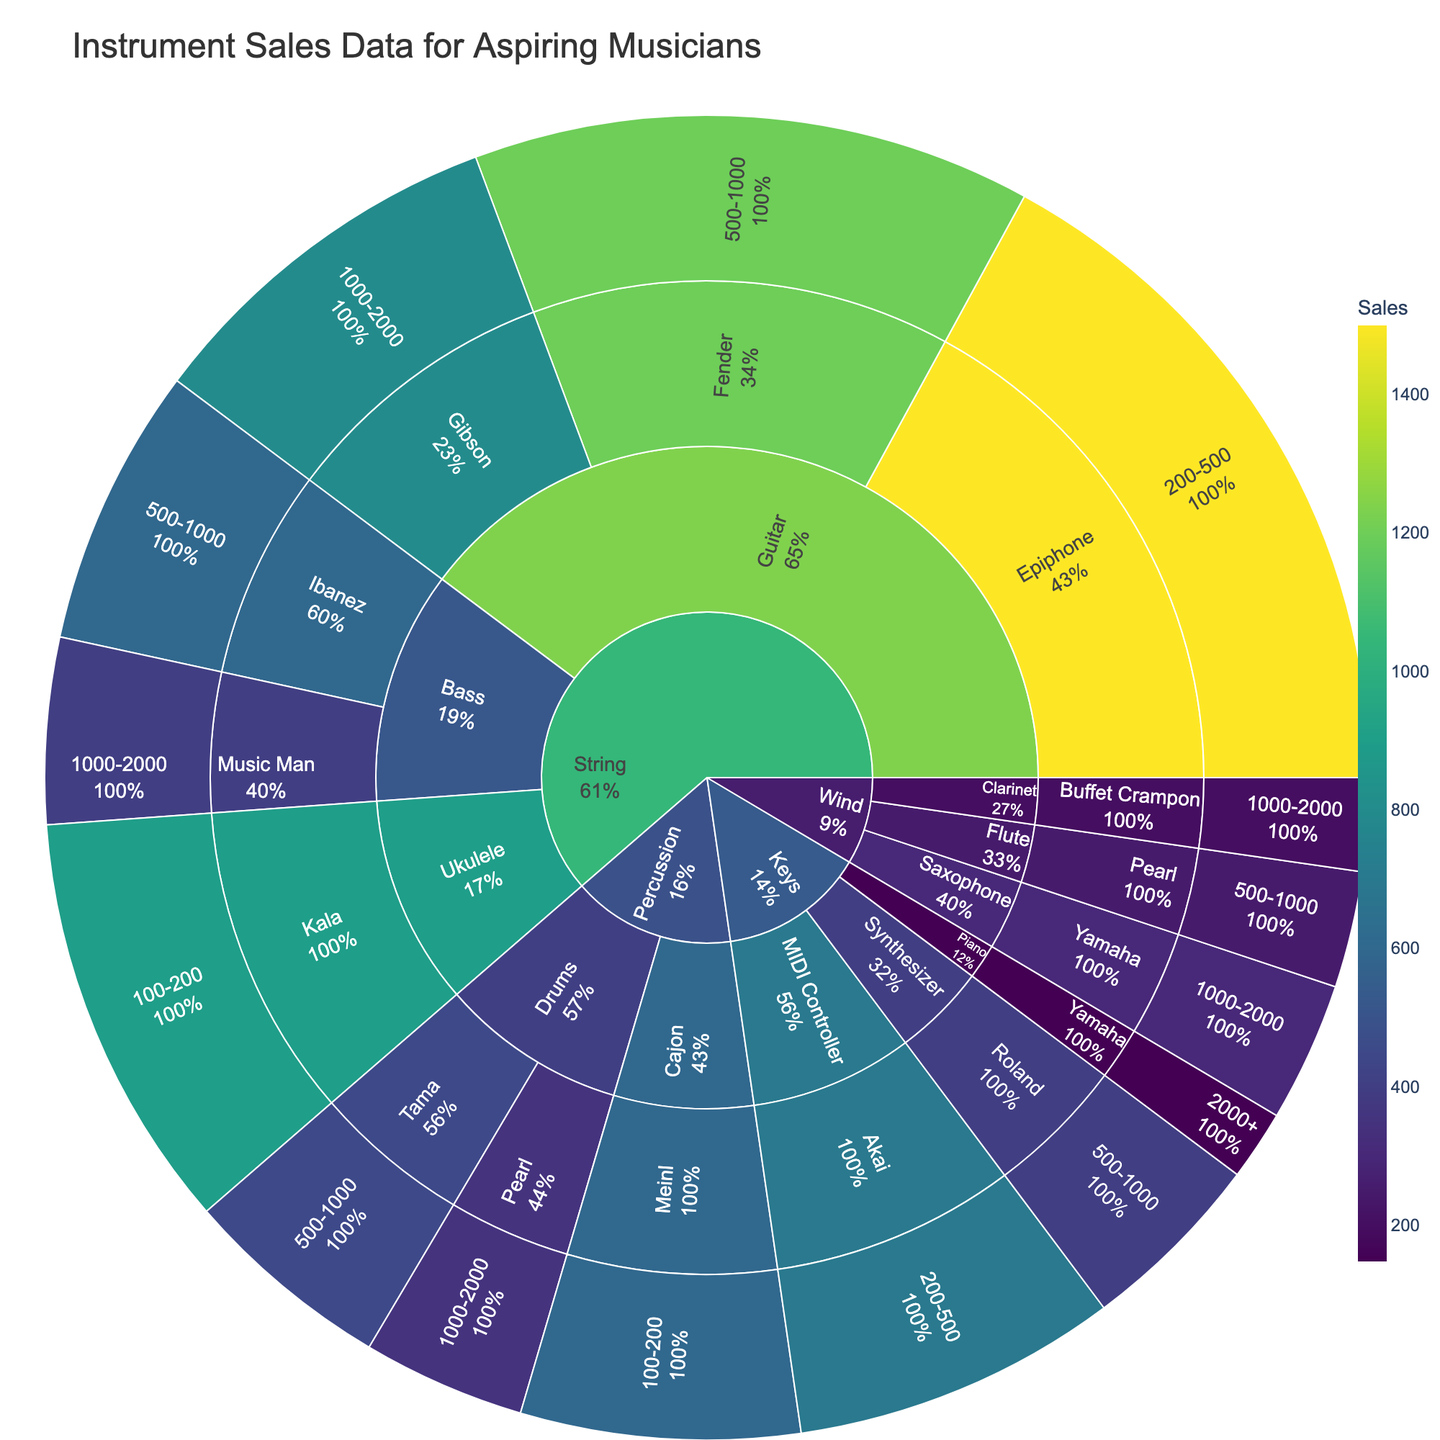what's the sales volume for Epiphone guitars? Locate the "Epiphone" brand under the "Guitar" type, then refer to the sales value associated with it, which is visible in the chart.
Answer: 1,500 which brand of drums has higher sales—Pearl or Tama? Look at the sales volumes for both Pearl and Tama under the "Drums" section of the "Percussion" category and compare them. Pearl has sales of 350, and Tama has sales of 450.
Answer: Tama what percentage of guitar sales are from the Fender brand? Identify the total sales under the "Guitar" type and calculate the percentage for Fender. The total guitar sales are 3,500 (1,200 Fender + 800 Gibson + 1,500 Epiphone). Fender's percentage is \( \frac{1200}{3500} \approx 34.3\% \).
Answer: 34.3% which instrument type has the highest total sales volume? Sum the individual sales volumes for each instrument type and compare them. Sum up sales for each type: String (5,400), Wind (750), Percussion (1,400), and Keys (1,250).
Answer: String how do sales of flutes compare to those of clarinets? Locate the sales values for flutes (250) and clarinets (200) within the Wind category, and compare them.
Answer: Flutes have higher sales within the $500-$1000 range, which brand and type combination has the highest sales? Locate all brand and type combinations within the $500-$1000 price range and check their sales volumes. Compare these values. Ibanez (600) under Bass has the highest within this range.
Answer: Ibanez Bass if we combine the sales of all Yamaha instruments across different types, what is the total sales volume? Identify and sum all sales values for Yamaha instruments across different types: Saxophone (300) and Piano (150).
Answer: 450 which type of instrument within the percussion category has the lowest sales volume? Compare the sales figures under the Percussion category: Drums (Pearl 350, Tama 450) and Cajon (Meinl 600). Pearl branded drums have the lowest sales.
Answer: Drums (Pearl) what’s the price range with the highest sales in the String category? For each price range within the String category, sum up the sales and identify the range with the highest total. 200-500 has the highest sales due to Epiphone (1500).
Answer: 200–500 how much more are the sales of synthesizers compared to MIDI controllers? Find the sales values for synthesizers (400) and MIDI controllers (700), then calculate the difference. 700 - 400 = 300 more sales for MIDI controllers.
Answer: -300 (synthesizers are lower by 300) 